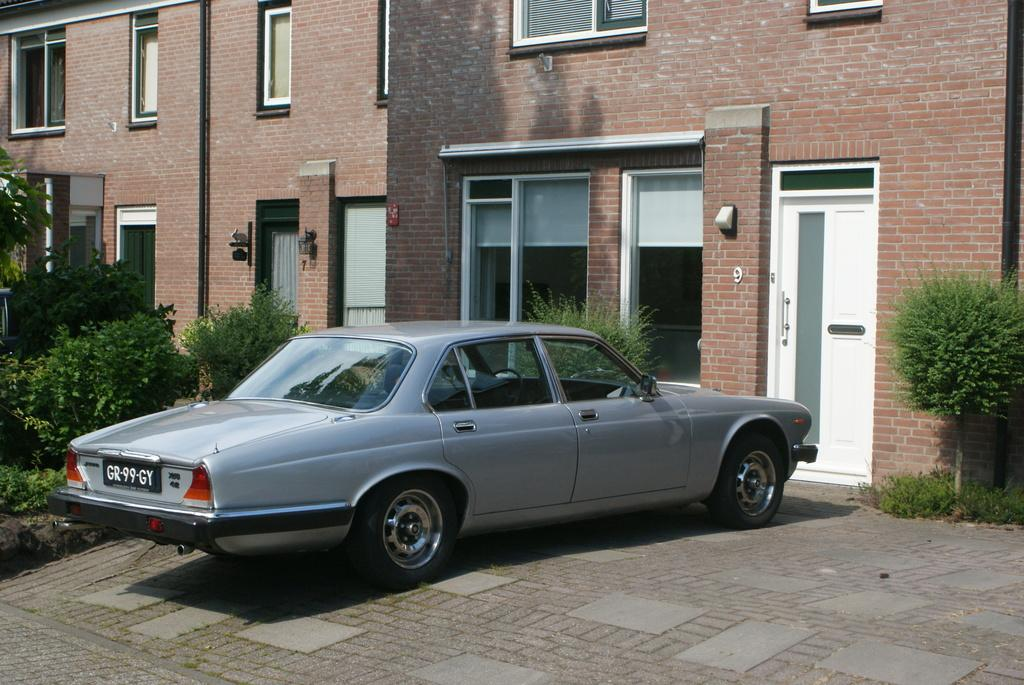What type of structure is visible in the image? There is a building in the image. What features can be seen on the building? The building has windows and a door. What is located in front of the building? There are plants and a car parked in front of the building. What type of toothpaste is being used to support the building in the image? There is no toothpaste present in the image, and toothpaste is not used to support buildings. 